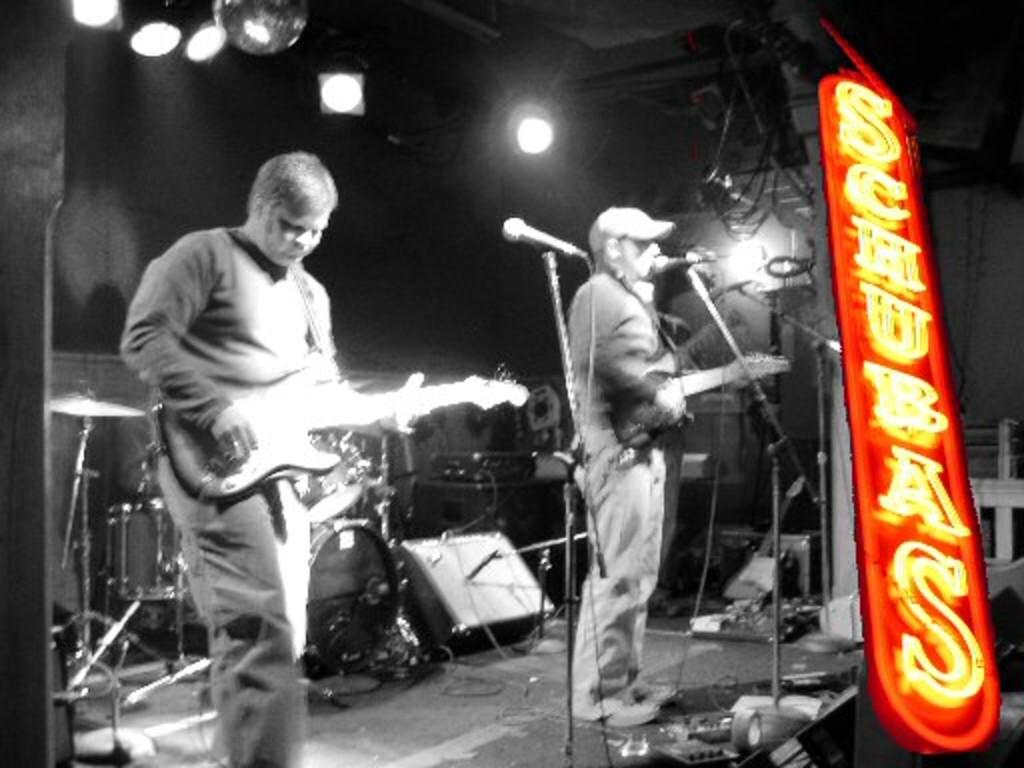How many men are in the image? There are two men in the image. What are the men doing in the image? The men are standing and holding guitars. What equipment is present in the image for amplifying sound? There are microphones with stands in the image. What type of objects are present in the image that are related to music? Musical instruments, such as guitars, and cables are visible in the image. What type of lighting is present in the image? Lights are present in the image. What additional object can be seen in the image? There is a board in the image. What type of dress is the chicken wearing in the image? There is no chicken present in the image, and therefore no dress or any clothing can be observed. 